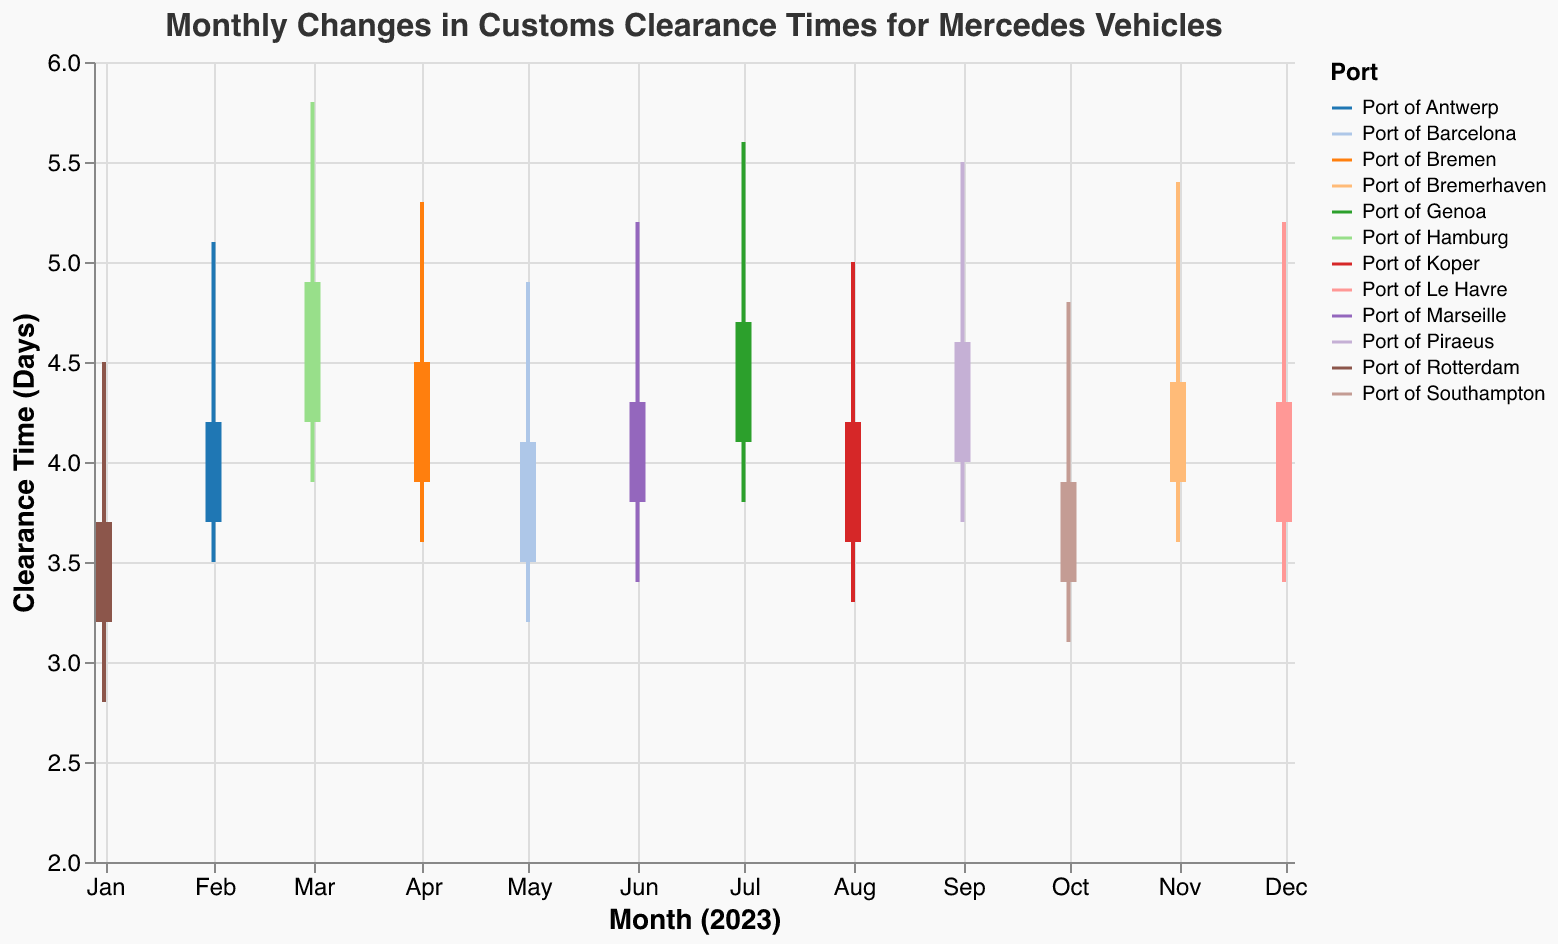What is the title of the figure? The title is usually displayed at the top of the figure. It reads: "Monthly Changes in Customs Clearance Times for Mercedes Vehicles."
Answer: Monthly Changes in Customs Clearance Times for Mercedes Vehicles What is the clearance time range for the Port of Hamburg in March 2023? Look at the data for March 2023 (Port of Hamburg) and find the values for "High" and "Low". The range is from the low value to the high value: 3.9 to 5.8 days.
Answer: 3.9 to 5.8 days Which port had the highest clearance time in August 2023, and what was that time? Look at the data for August 2023. The "High" value for the Port of Koper is 5.0 days, which is the highest value in that month.
Answer: Port of Koper, 5.0 days What is the average closing clearance time for all the ports in the first quarter of 2023 (Jan-Mar)? Sum the closing times for Jan (3.7), Feb (4.2), and Mar (4.9), then divide by 3. The average = (3.7 + 4.2 + 4.9) / 3 = 4.27 days.
Answer: 4.27 days Which month experienced the lowest opening clearance time and at which port did this occur? Look at all the "Open" values for each month. The lowest opening clearance time is 3.2 days in January 2023 at the Port of Rotterdam.
Answer: January 2023, Port of Rotterdam How does the clearance time in June 2023 at the Port of Marseille compare to the clearance time in July 2023 at the Port of Genoa? Compare the "Close" values for June (4.3) and July (4.7). July at the Port of Genoa has a higher clearance time than June at the Port of Marseille.
Answer: July is higher What is the median closing clearance time for all ports in 2023? List all the "Close" values in ascending order. The median is the middle value in an ordered list of 12 values. The ordered list is: [3.7, 3.9, 4.1, 4.2, 4.2, 4.3, 4.3, 4.4, 4.5, 4.6, 4.7, 4.9]. The median (average of the 6th and 7th values) = (4.3 + 4.3) / 2 = 4.3 days.
Answer: 4.3 days What was the clearance time fluctuation at the Port of Bremerhaven in November 2023? The fluctuation range is from the "Low" value to the "High" value in November 2023. The range is 3.6 to 5.4 days.
Answer: 3.6 to 5.4 days Which port had the smallest difference between its highest and lowest clearance times, and what was the difference? Calculate the difference (High - Low) for each port. The smallest difference is found for the Port of Barcelona (4.9 - 3.2 = 1.7 days).
Answer: Port of Barcelona, 1.7 days 